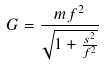<formula> <loc_0><loc_0><loc_500><loc_500>G = \frac { m f ^ { 2 } } { \sqrt { 1 + \frac { s ^ { 2 } } { f ^ { 2 } } } }</formula> 